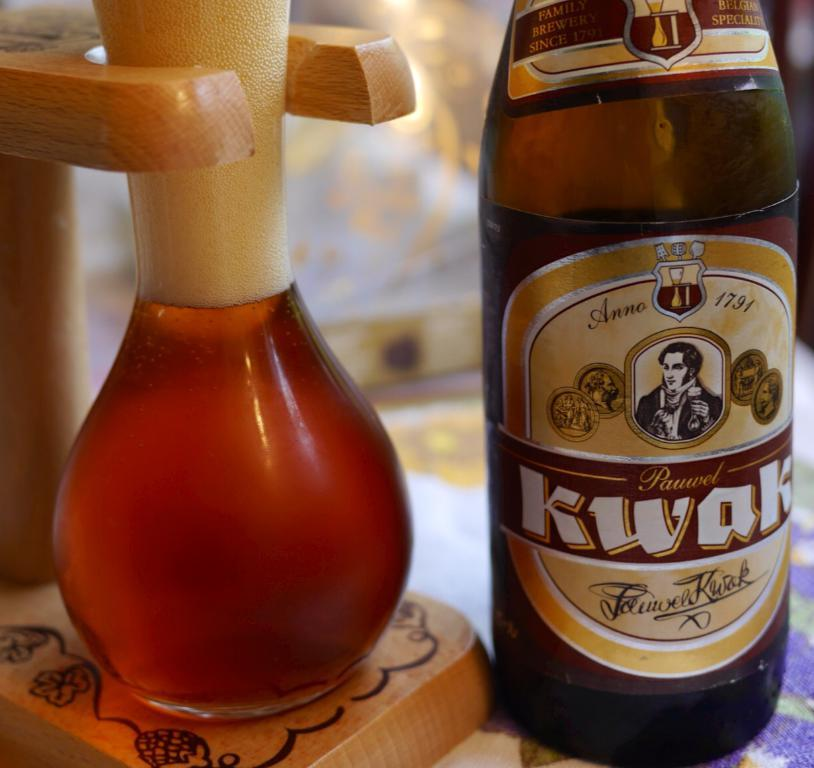<image>
Give a short and clear explanation of the subsequent image. Bottle of Kwak beer and a glass full of beer 